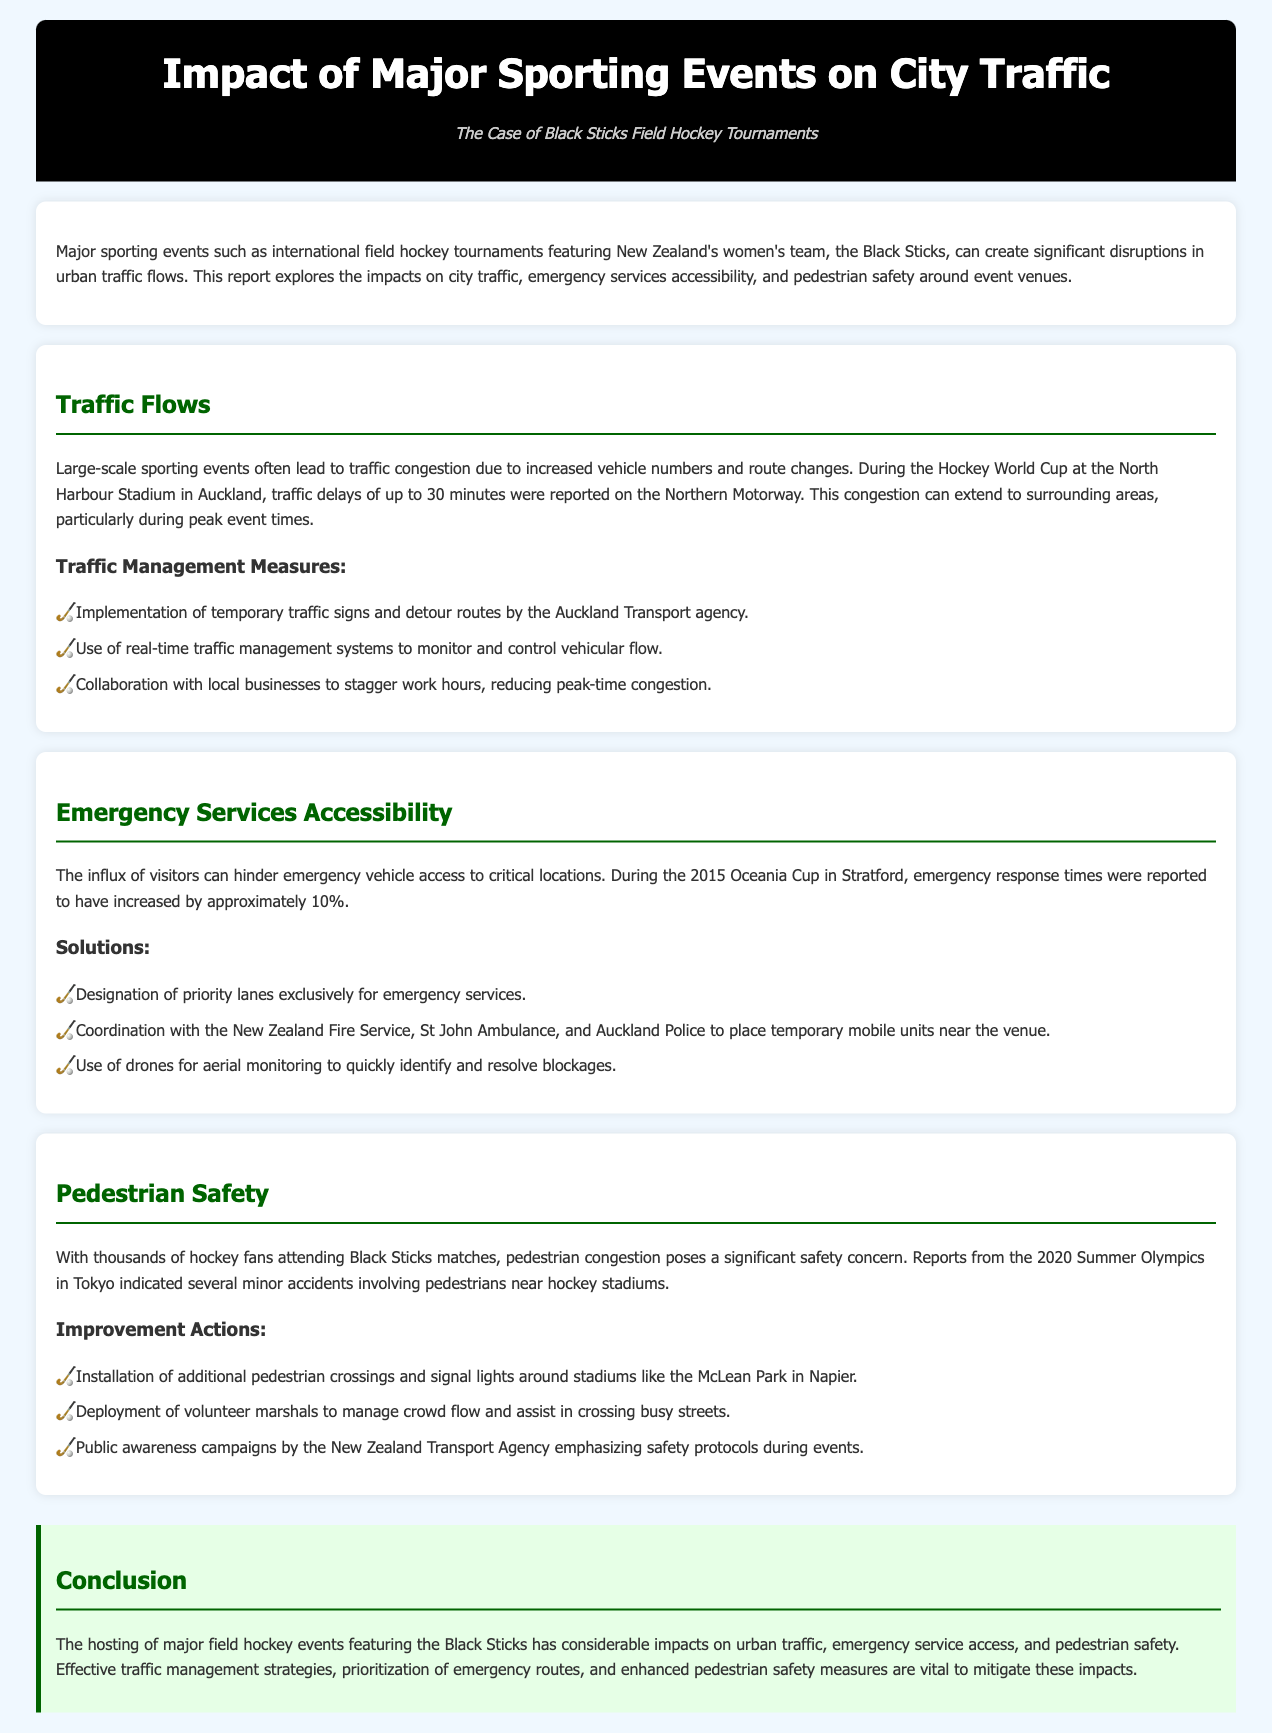what is the title of the report? The title of the report is explicitly stated in the header as "Impact of Major Sporting Events on City Traffic."
Answer: Impact of Major Sporting Events on City Traffic who are the featured players in the sporting events discussed? The document specifically mentions New Zealand's women's field hockey team, also known as the Black Sticks.
Answer: Black Sticks how much traffic delay was reported during the Hockey World Cup? The document states that traffic delays of up to 30 minutes were reported on the Northern Motorway during the Hockey World Cup.
Answer: 30 minutes what percentage increase in emergency response times was reported during the 2015 Oceania Cup? The document notes a 10% increase in emergency response times during this event.
Answer: 10% which traffic management measure involves collaboration with local businesses? The document refers to staggering work hours as a traffic management measure that involves collaboration with local businesses.
Answer: Staggering work hours what is one of the actions taken to improve pedestrian safety around stadiums? The report mentions the installation of additional pedestrian crossings as an action to improve pedestrian safety.
Answer: Installation of additional pedestrian crossings which organization is responsible for public awareness campaigns regarding safety protocols? The document identifies the New Zealand Transport Agency as the organization responsible for these campaigns.
Answer: New Zealand Transport Agency what type of monitoring system is mentioned for traffic management? The report mentions the use of real-time traffic management systems to monitor vehicular flow.
Answer: Real-time traffic management systems where was the 2015 Oceania Cup held? The document states that the 2015 Oceania Cup took place in Stratford.
Answer: Stratford 